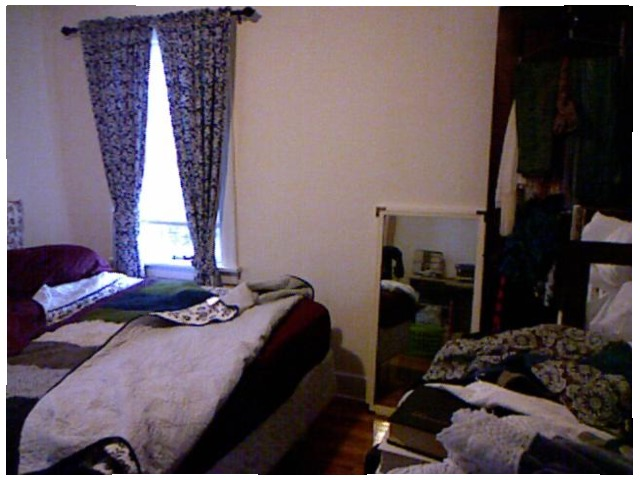<image>
Is there a mirror on the floor? Yes. Looking at the image, I can see the mirror is positioned on top of the floor, with the floor providing support. Where is the window in relation to the bed? Is it behind the bed? Yes. From this viewpoint, the window is positioned behind the bed, with the bed partially or fully occluding the window. 